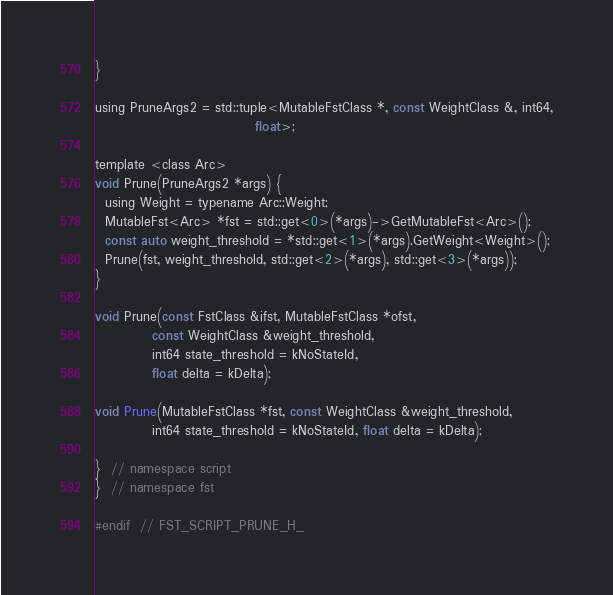Convert code to text. <code><loc_0><loc_0><loc_500><loc_500><_C_>}

using PruneArgs2 = std::tuple<MutableFstClass *, const WeightClass &, int64,
                               float>;

template <class Arc>
void Prune(PruneArgs2 *args) {
  using Weight = typename Arc::Weight;
  MutableFst<Arc> *fst = std::get<0>(*args)->GetMutableFst<Arc>();
  const auto weight_threshold = *std::get<1>(*args).GetWeight<Weight>();
  Prune(fst, weight_threshold, std::get<2>(*args), std::get<3>(*args));
}

void Prune(const FstClass &ifst, MutableFstClass *ofst,
           const WeightClass &weight_threshold,
           int64 state_threshold = kNoStateId,
           float delta = kDelta);

void Prune(MutableFstClass *fst, const WeightClass &weight_threshold,
           int64 state_threshold = kNoStateId, float delta = kDelta);

}  // namespace script
}  // namespace fst

#endif  // FST_SCRIPT_PRUNE_H_
</code> 